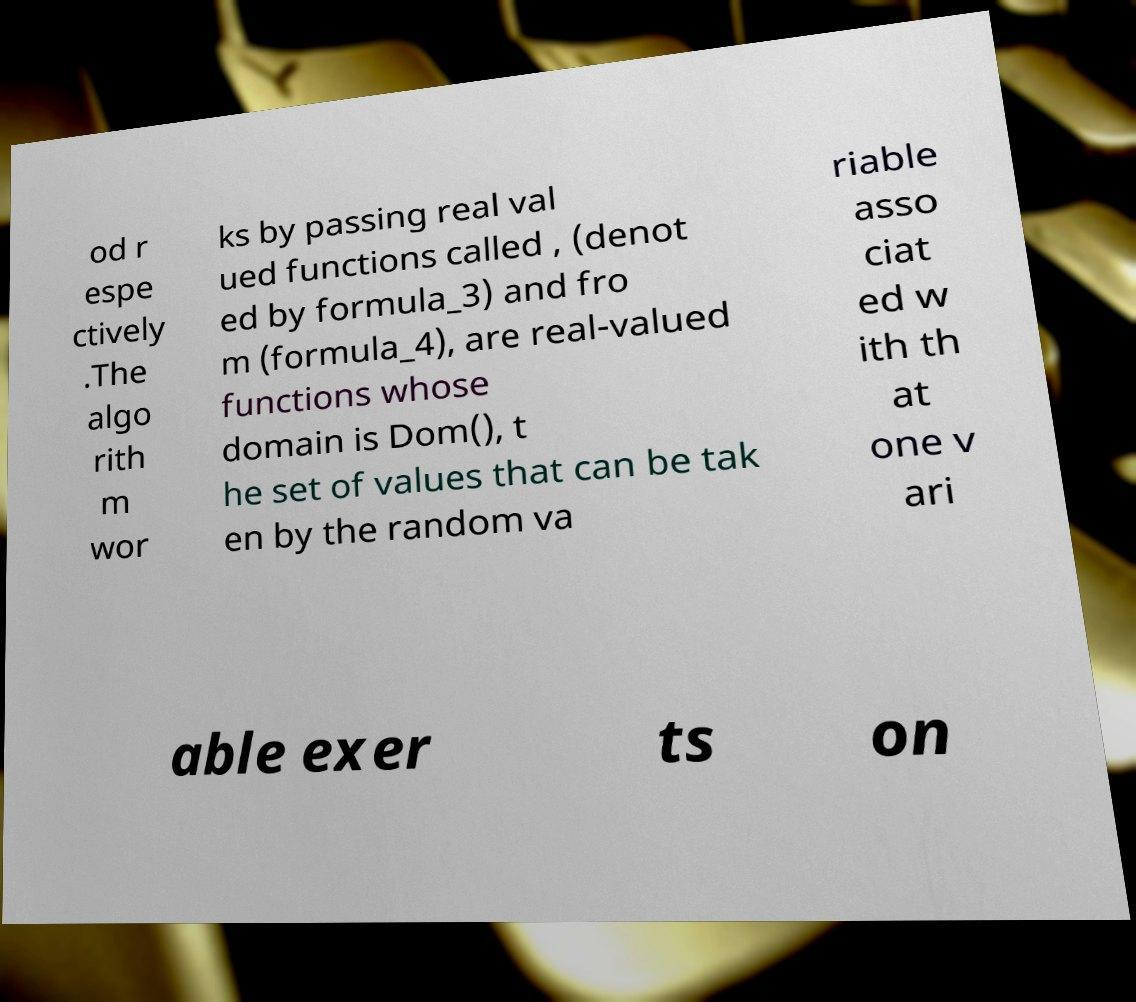Could you extract and type out the text from this image? od r espe ctively .The algo rith m wor ks by passing real val ued functions called , (denot ed by formula_3) and fro m (formula_4), are real-valued functions whose domain is Dom(), t he set of values that can be tak en by the random va riable asso ciat ed w ith th at one v ari able exer ts on 